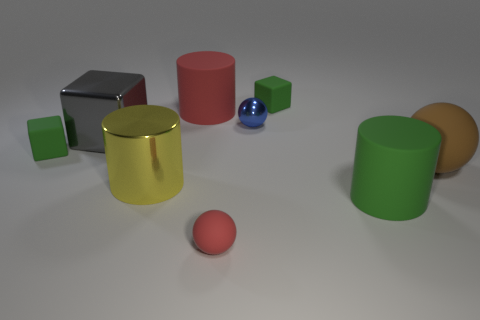Add 1 small cubes. How many objects exist? 10 Subtract all spheres. How many objects are left? 6 Add 4 cylinders. How many cylinders are left? 7 Add 3 red rubber things. How many red rubber things exist? 5 Subtract 1 green cylinders. How many objects are left? 8 Subtract all yellow metallic things. Subtract all blue shiny balls. How many objects are left? 7 